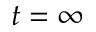Convert formula to latex. <formula><loc_0><loc_0><loc_500><loc_500>t = \infty</formula> 